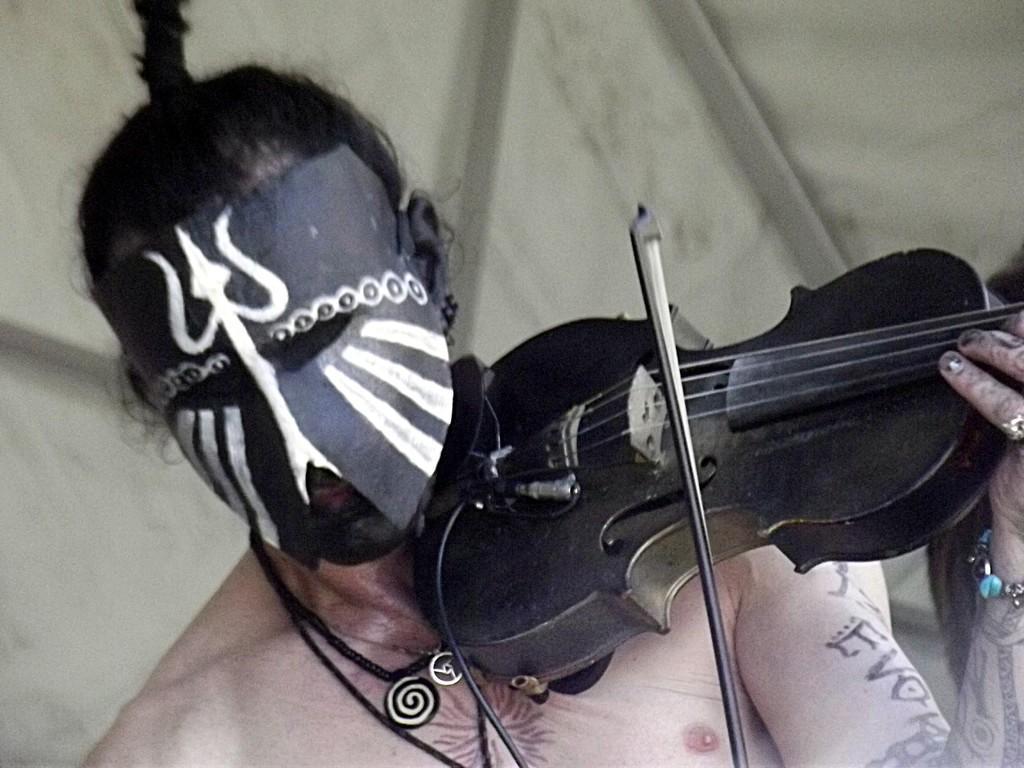In one or two sentences, can you explain what this image depicts? In this image, we can see a person wearing a mask and playing a musical instrument. In the background, we can see a curtain. 